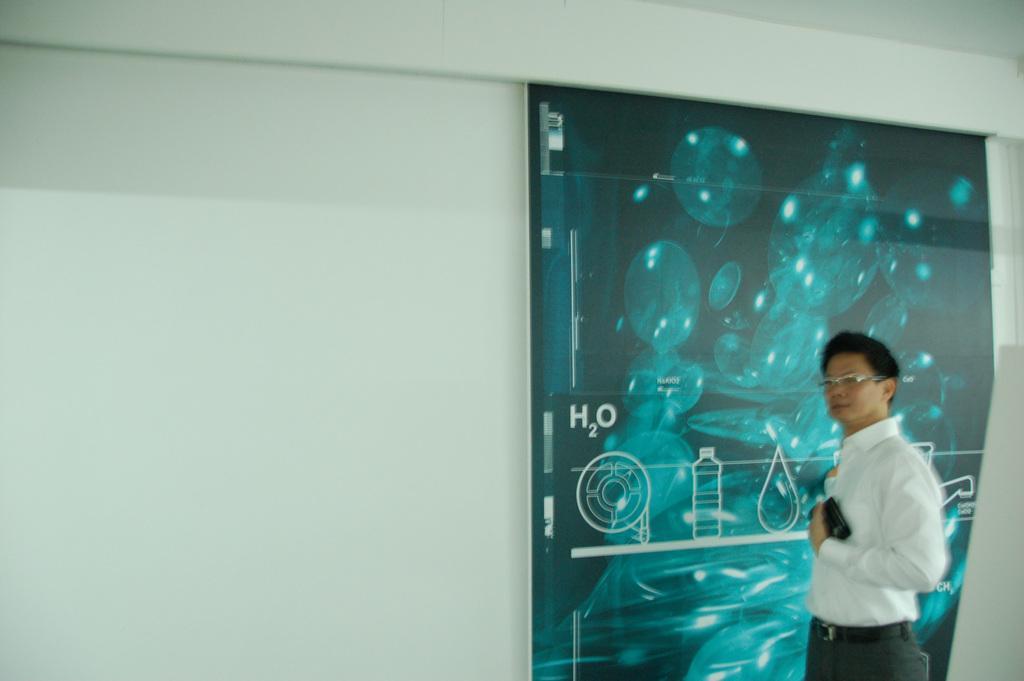In one or two sentences, can you explain what this image depicts? In this image we can see a person wearing spectacles is holding an object in his hand. In the background, we can see a banner with some text on the wall. 